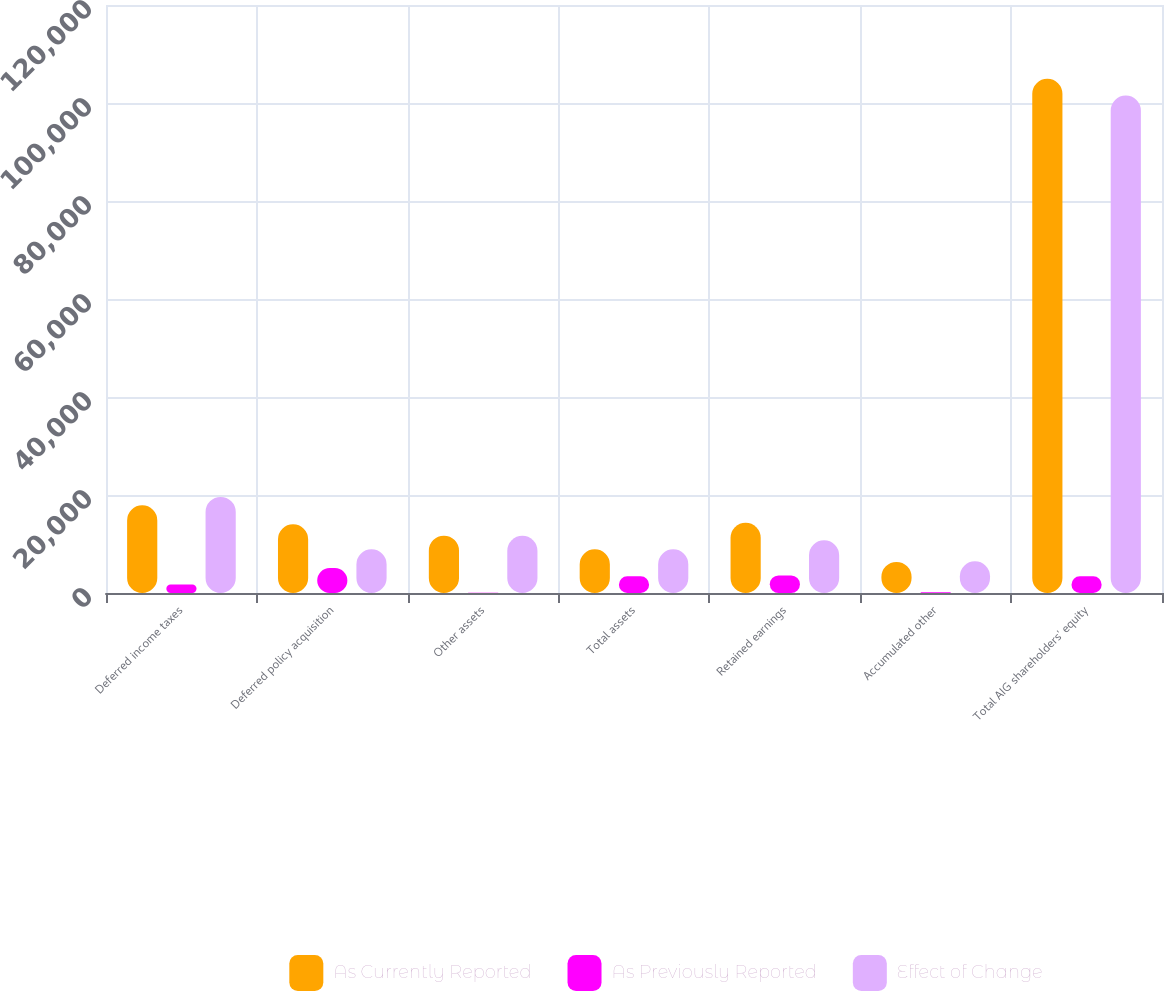<chart> <loc_0><loc_0><loc_500><loc_500><stacked_bar_chart><ecel><fcel>Deferred income taxes<fcel>Deferred policy acquisition<fcel>Other assets<fcel>Total assets<fcel>Retained earnings<fcel>Accumulated other<fcel>Total AIG shareholders' equity<nl><fcel>As Currently Reported<fcel>17897<fcel>14026<fcel>11705<fcel>8937<fcel>14332<fcel>6336<fcel>104951<nl><fcel>As Previously Reported<fcel>1718<fcel>5089<fcel>42<fcel>3413<fcel>3558<fcel>145<fcel>3413<nl><fcel>Effect of Change<fcel>19615<fcel>8937<fcel>11663<fcel>8937<fcel>10774<fcel>6481<fcel>101538<nl></chart> 